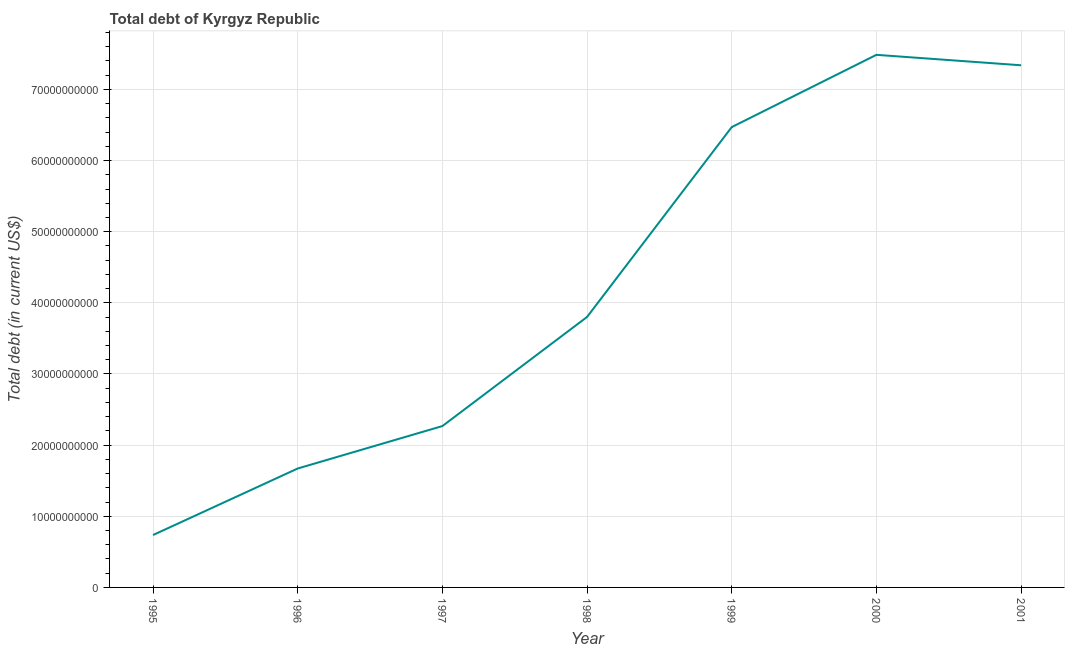What is the total debt in 1999?
Your answer should be very brief. 6.47e+1. Across all years, what is the maximum total debt?
Provide a succinct answer. 7.49e+1. Across all years, what is the minimum total debt?
Your answer should be very brief. 7.36e+09. In which year was the total debt maximum?
Keep it short and to the point. 2000. What is the sum of the total debt?
Give a very brief answer. 2.98e+11. What is the difference between the total debt in 1997 and 2000?
Ensure brevity in your answer.  -5.22e+1. What is the average total debt per year?
Your answer should be compact. 4.25e+1. What is the median total debt?
Give a very brief answer. 3.80e+1. In how many years, is the total debt greater than 44000000000 US$?
Offer a terse response. 3. What is the ratio of the total debt in 1996 to that in 2001?
Provide a short and direct response. 0.23. Is the total debt in 1997 less than that in 1999?
Make the answer very short. Yes. Is the difference between the total debt in 1997 and 1999 greater than the difference between any two years?
Your answer should be compact. No. What is the difference between the highest and the second highest total debt?
Keep it short and to the point. 1.47e+09. Is the sum of the total debt in 1995 and 2000 greater than the maximum total debt across all years?
Your response must be concise. Yes. What is the difference between the highest and the lowest total debt?
Ensure brevity in your answer.  6.75e+1. In how many years, is the total debt greater than the average total debt taken over all years?
Your answer should be very brief. 3. Does the total debt monotonically increase over the years?
Give a very brief answer. No. How many years are there in the graph?
Your response must be concise. 7. Are the values on the major ticks of Y-axis written in scientific E-notation?
Your answer should be very brief. No. What is the title of the graph?
Keep it short and to the point. Total debt of Kyrgyz Republic. What is the label or title of the Y-axis?
Your answer should be compact. Total debt (in current US$). What is the Total debt (in current US$) of 1995?
Make the answer very short. 7.36e+09. What is the Total debt (in current US$) of 1996?
Provide a short and direct response. 1.67e+1. What is the Total debt (in current US$) in 1997?
Offer a terse response. 2.27e+1. What is the Total debt (in current US$) of 1998?
Offer a very short reply. 3.80e+1. What is the Total debt (in current US$) of 1999?
Give a very brief answer. 6.47e+1. What is the Total debt (in current US$) of 2000?
Offer a terse response. 7.49e+1. What is the Total debt (in current US$) of 2001?
Keep it short and to the point. 7.34e+1. What is the difference between the Total debt (in current US$) in 1995 and 1996?
Offer a terse response. -9.35e+09. What is the difference between the Total debt (in current US$) in 1995 and 1997?
Provide a short and direct response. -1.53e+1. What is the difference between the Total debt (in current US$) in 1995 and 1998?
Give a very brief answer. -3.07e+1. What is the difference between the Total debt (in current US$) in 1995 and 1999?
Keep it short and to the point. -5.73e+1. What is the difference between the Total debt (in current US$) in 1995 and 2000?
Offer a very short reply. -6.75e+1. What is the difference between the Total debt (in current US$) in 1995 and 2001?
Provide a short and direct response. -6.60e+1. What is the difference between the Total debt (in current US$) in 1996 and 1997?
Make the answer very short. -5.96e+09. What is the difference between the Total debt (in current US$) in 1996 and 1998?
Provide a short and direct response. -2.13e+1. What is the difference between the Total debt (in current US$) in 1996 and 1999?
Give a very brief answer. -4.80e+1. What is the difference between the Total debt (in current US$) in 1996 and 2000?
Your answer should be compact. -5.81e+1. What is the difference between the Total debt (in current US$) in 1996 and 2001?
Your answer should be compact. -5.67e+1. What is the difference between the Total debt (in current US$) in 1997 and 1998?
Provide a short and direct response. -1.53e+1. What is the difference between the Total debt (in current US$) in 1997 and 1999?
Your response must be concise. -4.20e+1. What is the difference between the Total debt (in current US$) in 1997 and 2000?
Your answer should be very brief. -5.22e+1. What is the difference between the Total debt (in current US$) in 1997 and 2001?
Offer a very short reply. -5.07e+1. What is the difference between the Total debt (in current US$) in 1998 and 1999?
Offer a very short reply. -2.67e+1. What is the difference between the Total debt (in current US$) in 1998 and 2000?
Offer a very short reply. -3.68e+1. What is the difference between the Total debt (in current US$) in 1998 and 2001?
Your response must be concise. -3.54e+1. What is the difference between the Total debt (in current US$) in 1999 and 2000?
Make the answer very short. -1.02e+1. What is the difference between the Total debt (in current US$) in 1999 and 2001?
Offer a terse response. -8.69e+09. What is the difference between the Total debt (in current US$) in 2000 and 2001?
Your answer should be compact. 1.47e+09. What is the ratio of the Total debt (in current US$) in 1995 to that in 1996?
Your answer should be very brief. 0.44. What is the ratio of the Total debt (in current US$) in 1995 to that in 1997?
Offer a terse response. 0.33. What is the ratio of the Total debt (in current US$) in 1995 to that in 1998?
Ensure brevity in your answer.  0.19. What is the ratio of the Total debt (in current US$) in 1995 to that in 1999?
Your answer should be very brief. 0.11. What is the ratio of the Total debt (in current US$) in 1995 to that in 2000?
Offer a terse response. 0.1. What is the ratio of the Total debt (in current US$) in 1995 to that in 2001?
Provide a succinct answer. 0.1. What is the ratio of the Total debt (in current US$) in 1996 to that in 1997?
Provide a short and direct response. 0.74. What is the ratio of the Total debt (in current US$) in 1996 to that in 1998?
Make the answer very short. 0.44. What is the ratio of the Total debt (in current US$) in 1996 to that in 1999?
Your answer should be compact. 0.26. What is the ratio of the Total debt (in current US$) in 1996 to that in 2000?
Ensure brevity in your answer.  0.22. What is the ratio of the Total debt (in current US$) in 1996 to that in 2001?
Give a very brief answer. 0.23. What is the ratio of the Total debt (in current US$) in 1997 to that in 1998?
Make the answer very short. 0.6. What is the ratio of the Total debt (in current US$) in 1997 to that in 1999?
Make the answer very short. 0.35. What is the ratio of the Total debt (in current US$) in 1997 to that in 2000?
Make the answer very short. 0.3. What is the ratio of the Total debt (in current US$) in 1997 to that in 2001?
Your answer should be very brief. 0.31. What is the ratio of the Total debt (in current US$) in 1998 to that in 1999?
Your response must be concise. 0.59. What is the ratio of the Total debt (in current US$) in 1998 to that in 2000?
Ensure brevity in your answer.  0.51. What is the ratio of the Total debt (in current US$) in 1998 to that in 2001?
Offer a terse response. 0.52. What is the ratio of the Total debt (in current US$) in 1999 to that in 2000?
Provide a succinct answer. 0.86. What is the ratio of the Total debt (in current US$) in 1999 to that in 2001?
Your answer should be compact. 0.88. What is the ratio of the Total debt (in current US$) in 2000 to that in 2001?
Make the answer very short. 1.02. 